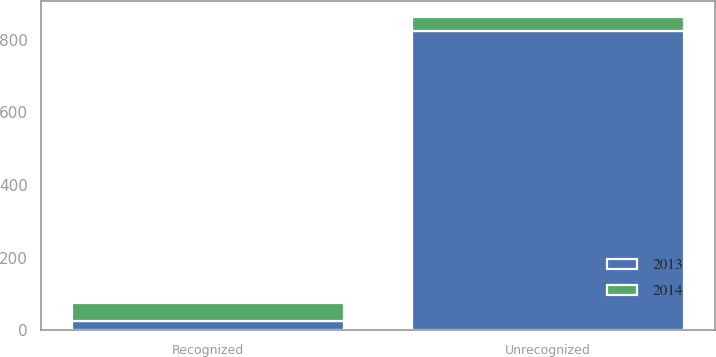Convert chart. <chart><loc_0><loc_0><loc_500><loc_500><stacked_bar_chart><ecel><fcel>Recognized<fcel>Unrecognized<nl><fcel>2013<fcel>25<fcel>823<nl><fcel>2014<fcel>51<fcel>40<nl></chart> 